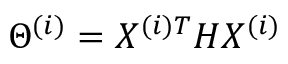<formula> <loc_0><loc_0><loc_500><loc_500>\Theta ^ { ( i ) } = X ^ { ( i ) T } H X ^ { ( i ) }</formula> 